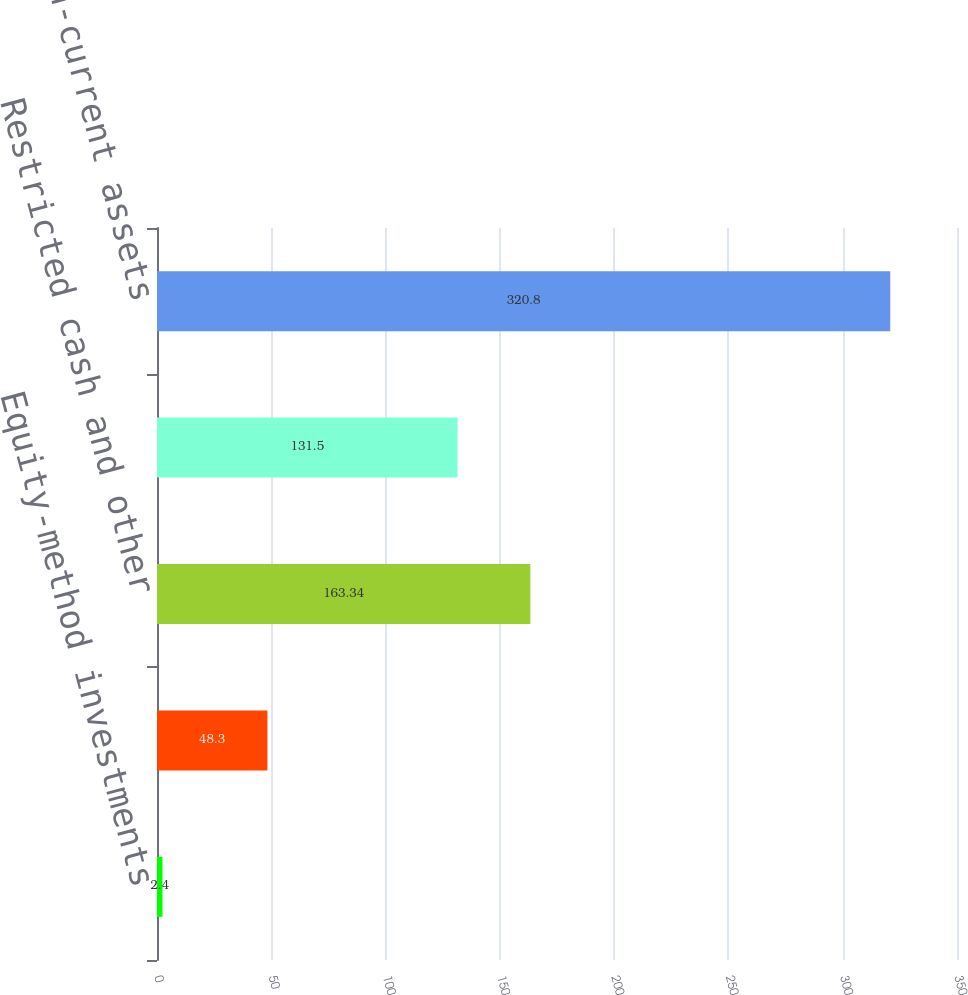Convert chart to OTSL. <chart><loc_0><loc_0><loc_500><loc_500><bar_chart><fcel>Equity-method investments<fcel>Officers' life insurance<fcel>Restricted cash and other<fcel>Other non-current assets<fcel>Total other non-current assets<nl><fcel>2.4<fcel>48.3<fcel>163.34<fcel>131.5<fcel>320.8<nl></chart> 